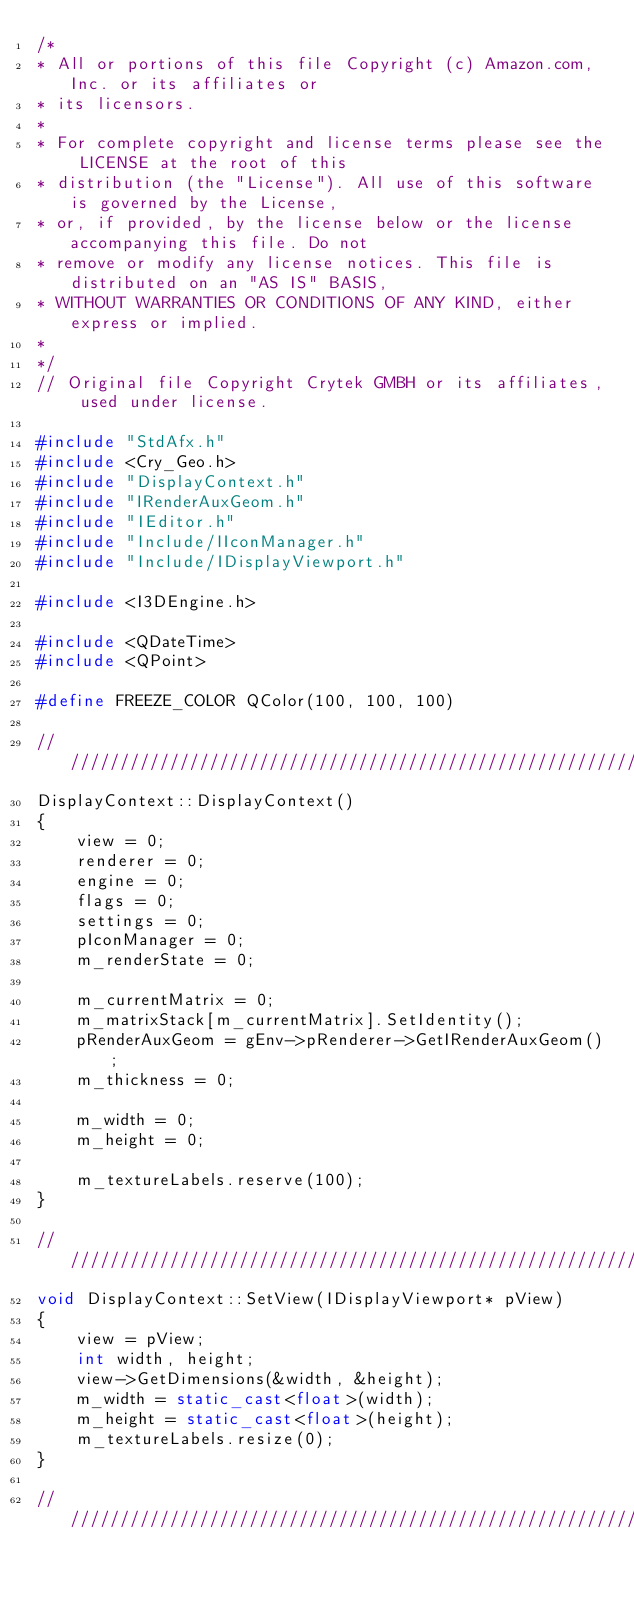Convert code to text. <code><loc_0><loc_0><loc_500><loc_500><_C++_>/*
* All or portions of this file Copyright (c) Amazon.com, Inc. or its affiliates or
* its licensors.
*
* For complete copyright and license terms please see the LICENSE at the root of this
* distribution (the "License"). All use of this software is governed by the License,
* or, if provided, by the license below or the license accompanying this file. Do not
* remove or modify any license notices. This file is distributed on an "AS IS" BASIS,
* WITHOUT WARRANTIES OR CONDITIONS OF ANY KIND, either express or implied.
*
*/
// Original file Copyright Crytek GMBH or its affiliates, used under license.

#include "StdAfx.h"
#include <Cry_Geo.h>
#include "DisplayContext.h"
#include "IRenderAuxGeom.h"
#include "IEditor.h"
#include "Include/IIconManager.h"
#include "Include/IDisplayViewport.h"

#include <I3DEngine.h>

#include <QDateTime>
#include <QPoint>

#define FREEZE_COLOR QColor(100, 100, 100)

//////////////////////////////////////////////////////////////////////////
DisplayContext::DisplayContext()
{
    view = 0;
    renderer = 0;
    engine = 0;
    flags = 0;
    settings = 0;
    pIconManager = 0;
    m_renderState = 0;

    m_currentMatrix = 0;
    m_matrixStack[m_currentMatrix].SetIdentity();
    pRenderAuxGeom = gEnv->pRenderer->GetIRenderAuxGeom();
    m_thickness = 0;

    m_width = 0;
    m_height = 0;

    m_textureLabels.reserve(100);
}

//////////////////////////////////////////////////////////////////////////
void DisplayContext::SetView(IDisplayViewport* pView)
{
    view = pView;
    int width, height;
    view->GetDimensions(&width, &height);
    m_width = static_cast<float>(width);
    m_height = static_cast<float>(height);
    m_textureLabels.resize(0);
}

//////////////////////////////////////////////////////////////////////////</code> 